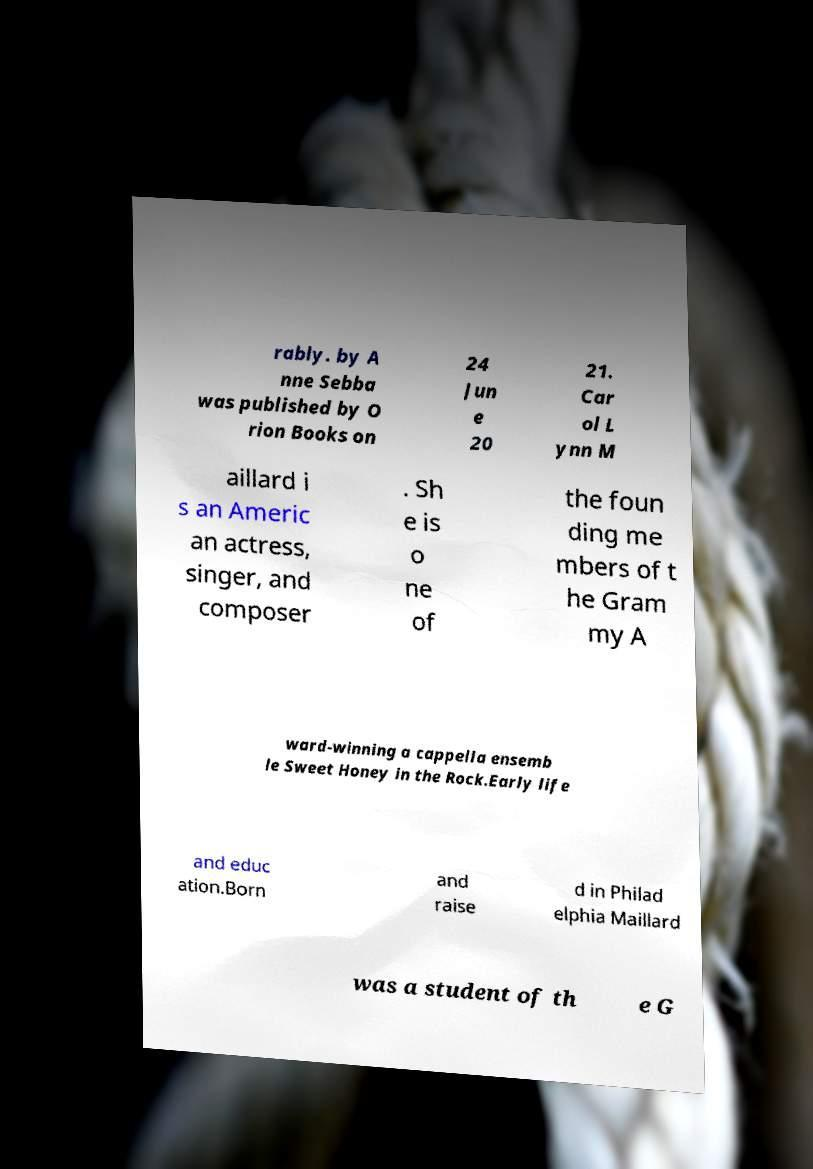I need the written content from this picture converted into text. Can you do that? rably. by A nne Sebba was published by O rion Books on 24 Jun e 20 21. Car ol L ynn M aillard i s an Americ an actress, singer, and composer . Sh e is o ne of the foun ding me mbers of t he Gram my A ward-winning a cappella ensemb le Sweet Honey in the Rock.Early life and educ ation.Born and raise d in Philad elphia Maillard was a student of th e G 